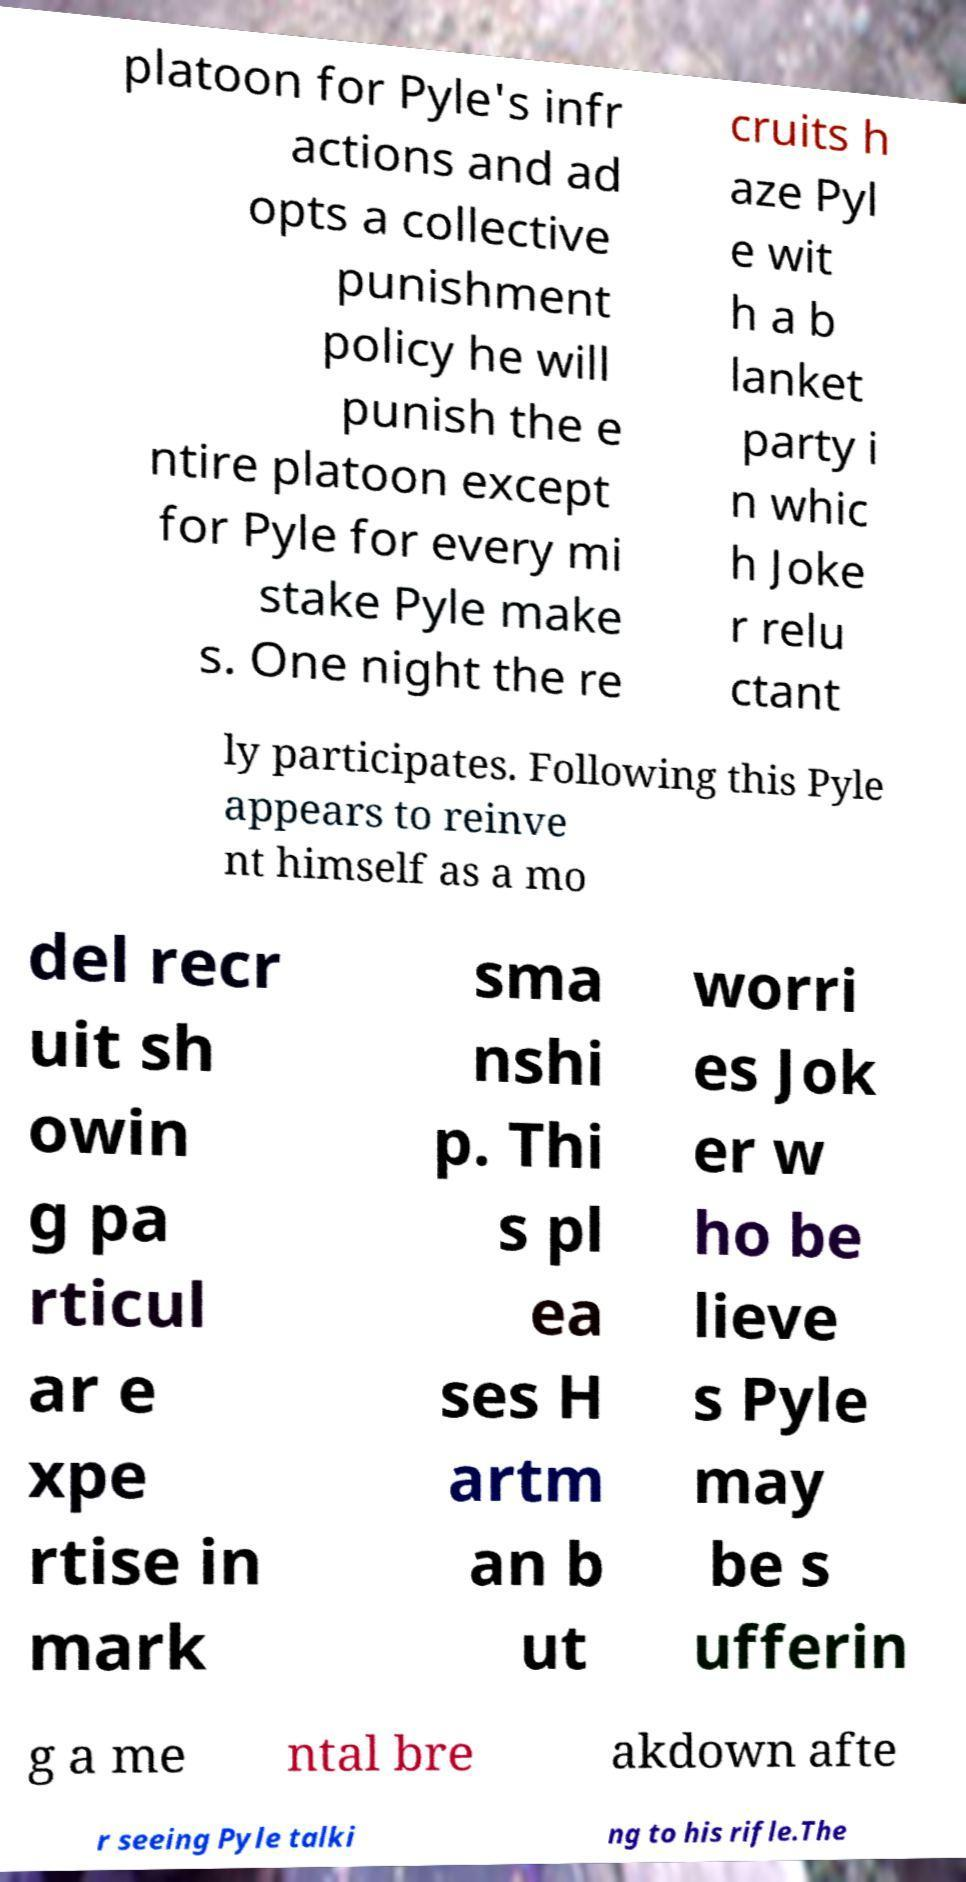Please read and relay the text visible in this image. What does it say? platoon for Pyle's infr actions and ad opts a collective punishment policy he will punish the e ntire platoon except for Pyle for every mi stake Pyle make s. One night the re cruits h aze Pyl e wit h a b lanket party i n whic h Joke r relu ctant ly participates. Following this Pyle appears to reinve nt himself as a mo del recr uit sh owin g pa rticul ar e xpe rtise in mark sma nshi p. Thi s pl ea ses H artm an b ut worri es Jok er w ho be lieve s Pyle may be s ufferin g a me ntal bre akdown afte r seeing Pyle talki ng to his rifle.The 